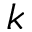<formula> <loc_0><loc_0><loc_500><loc_500>k</formula> 